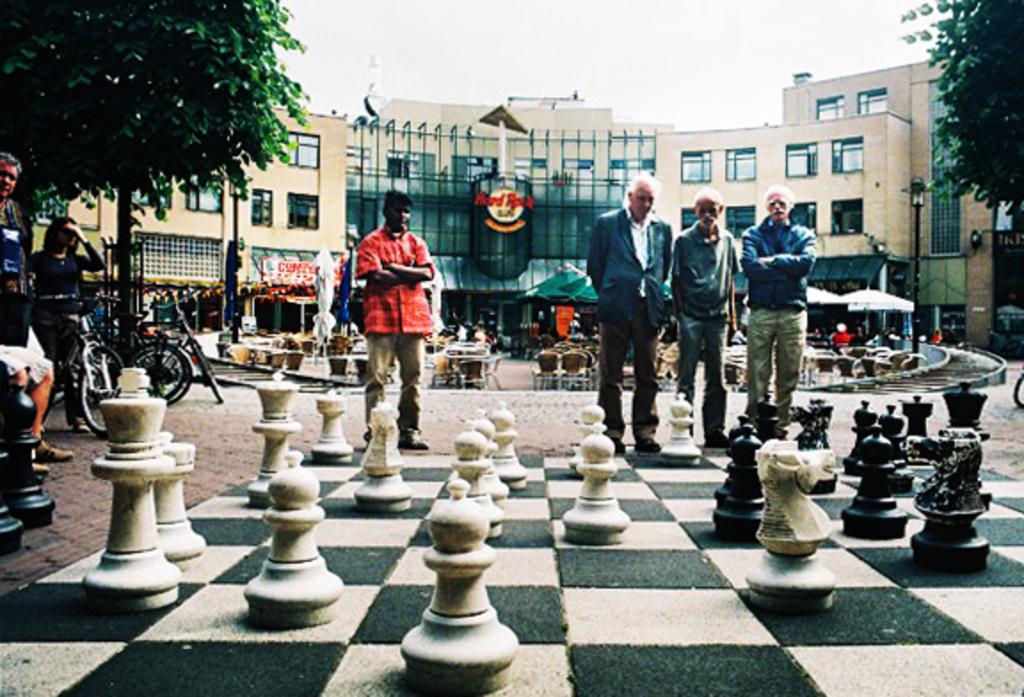What is the name of the restaurant in the middle?
Ensure brevity in your answer.  Hard rock cafe. 